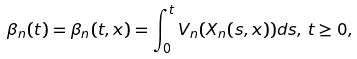Convert formula to latex. <formula><loc_0><loc_0><loc_500><loc_500>\beta _ { n } ( t ) = \beta _ { n } ( t , x ) = \int _ { 0 } ^ { t } { V _ { n } } ( X _ { n } ( s , x ) ) d s , \, t \geq 0 ,</formula> 